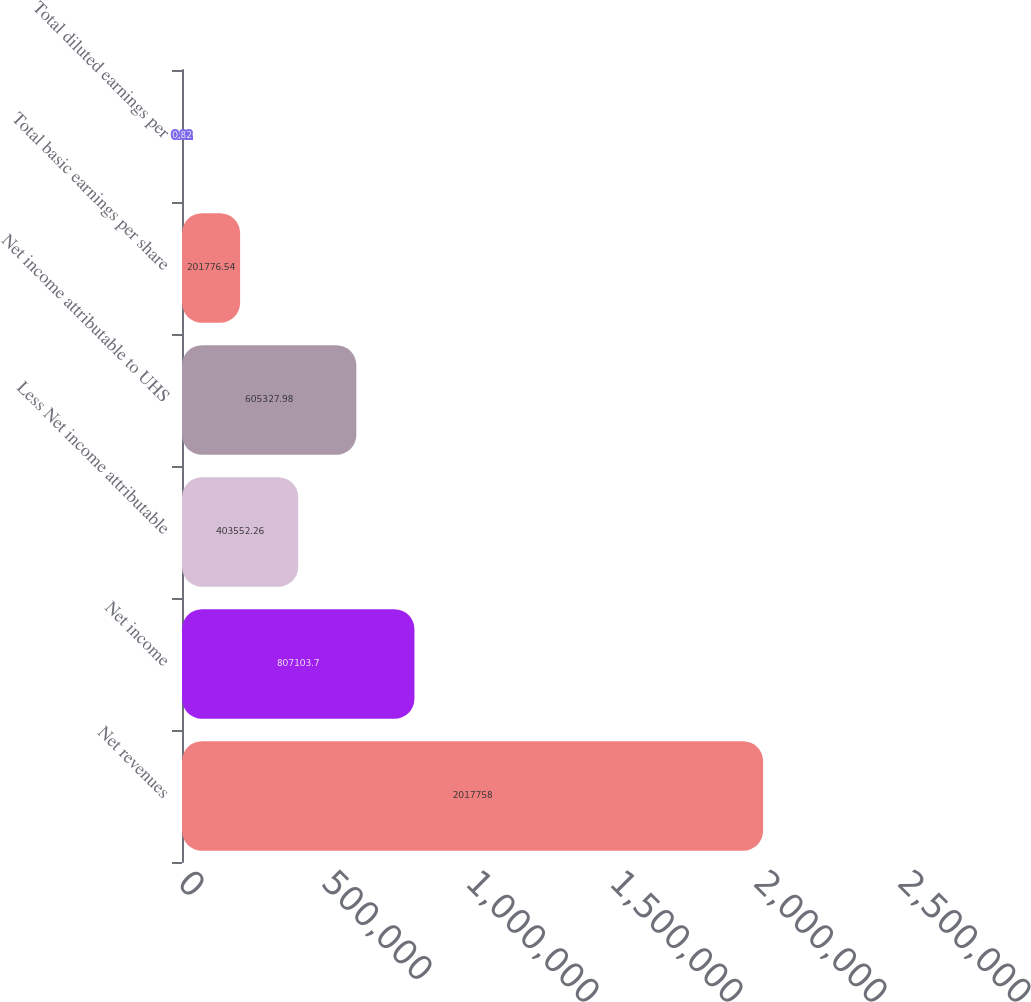Convert chart. <chart><loc_0><loc_0><loc_500><loc_500><bar_chart><fcel>Net revenues<fcel>Net income<fcel>Less Net income attributable<fcel>Net income attributable to UHS<fcel>Total basic earnings per share<fcel>Total diluted earnings per<nl><fcel>2.01776e+06<fcel>807104<fcel>403552<fcel>605328<fcel>201777<fcel>0.82<nl></chart> 